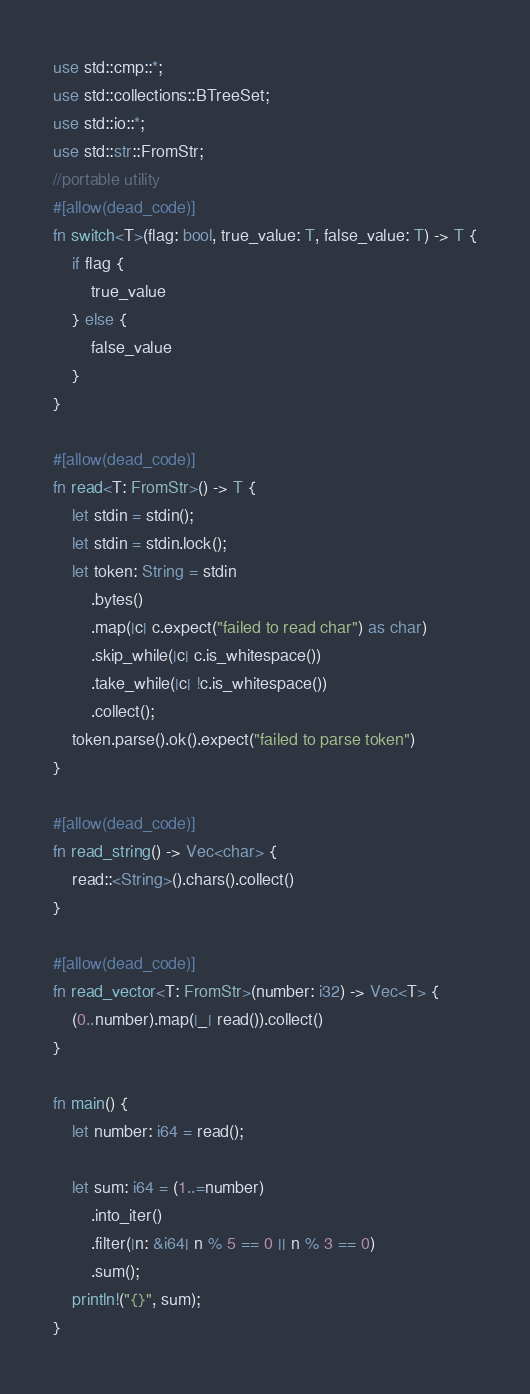<code> <loc_0><loc_0><loc_500><loc_500><_Rust_>use std::cmp::*;
use std::collections::BTreeSet;
use std::io::*;
use std::str::FromStr;
//portable utility
#[allow(dead_code)]
fn switch<T>(flag: bool, true_value: T, false_value: T) -> T {
    if flag {
        true_value
    } else {
        false_value
    }
}
 
#[allow(dead_code)]
fn read<T: FromStr>() -> T {
    let stdin = stdin();
    let stdin = stdin.lock();
    let token: String = stdin
        .bytes()
        .map(|c| c.expect("failed to read char") as char)
        .skip_while(|c| c.is_whitespace())
        .take_while(|c| !c.is_whitespace())
        .collect();
    token.parse().ok().expect("failed to parse token")
}
 
#[allow(dead_code)]
fn read_string() -> Vec<char> {
    read::<String>().chars().collect()
}
 
#[allow(dead_code)]
fn read_vector<T: FromStr>(number: i32) -> Vec<T> {
    (0..number).map(|_| read()).collect()
}
 
fn main() {
    let number: i64 = read();
 
    let sum: i64 = (1..=number)
        .into_iter()
        .filter(|n: &i64| n % 5 == 0 || n % 3 == 0)
        .sum();
    println!("{}", sum);
}</code> 